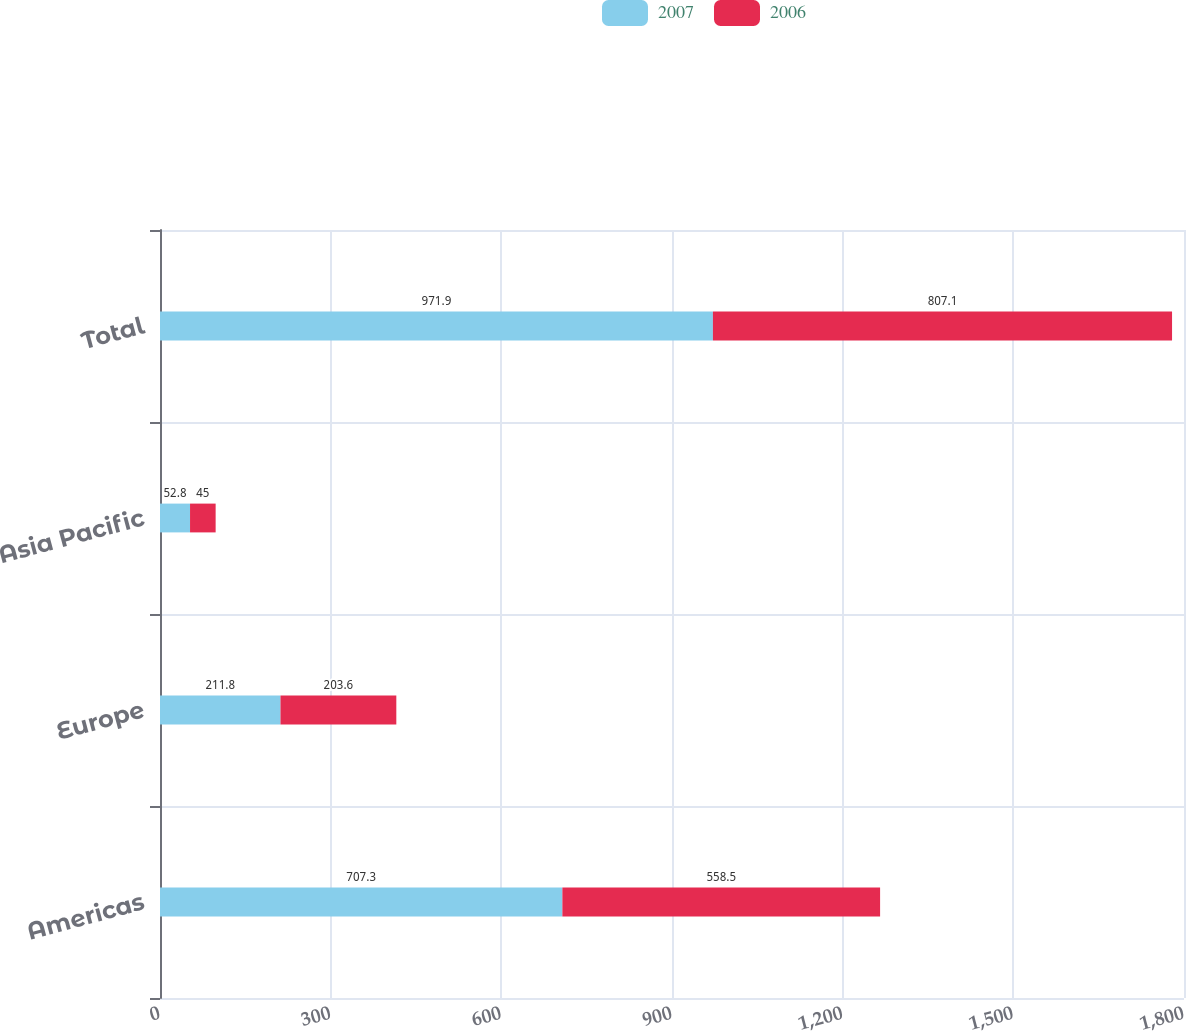<chart> <loc_0><loc_0><loc_500><loc_500><stacked_bar_chart><ecel><fcel>Americas<fcel>Europe<fcel>Asia Pacific<fcel>Total<nl><fcel>2007<fcel>707.3<fcel>211.8<fcel>52.8<fcel>971.9<nl><fcel>2006<fcel>558.5<fcel>203.6<fcel>45<fcel>807.1<nl></chart> 